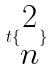<formula> <loc_0><loc_0><loc_500><loc_500>t \{ \begin{matrix} 2 \\ n \end{matrix} \}</formula> 